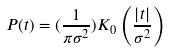<formula> <loc_0><loc_0><loc_500><loc_500>P ( t ) = ( \frac { 1 } { \pi \sigma ^ { 2 } } ) K _ { 0 } \left ( { \frac { \left | t \right | } { \sigma ^ { 2 } } } \right )</formula> 